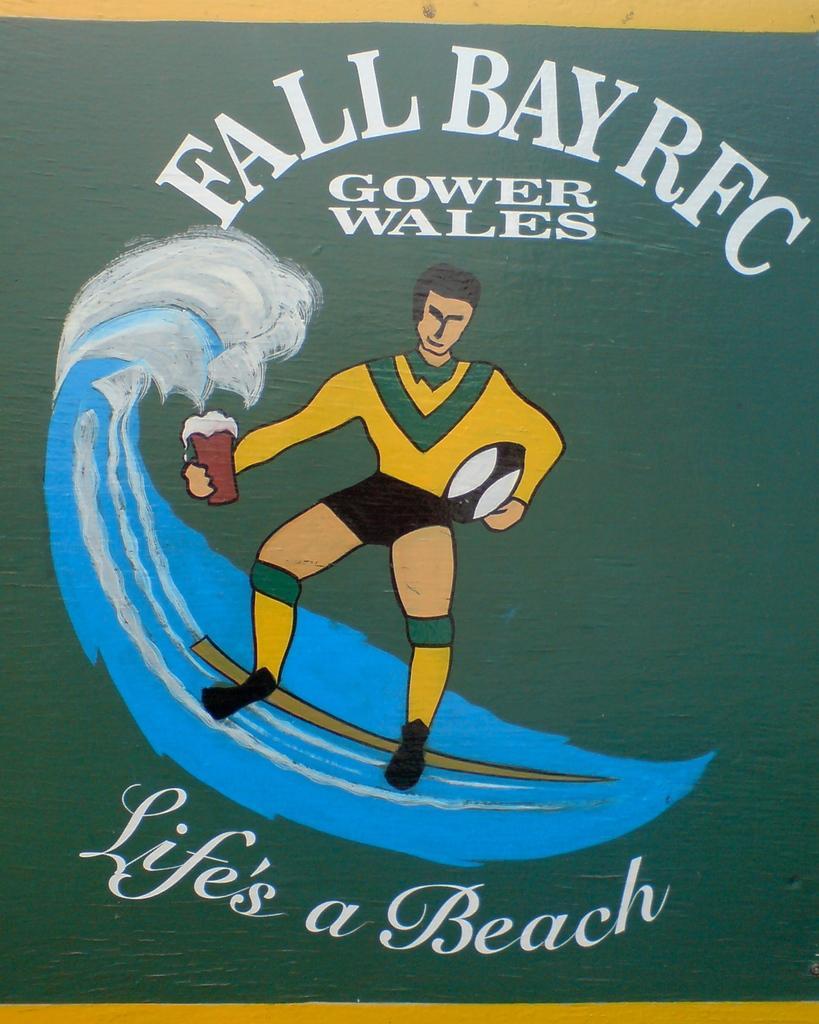In one or two sentences, can you explain what this image depicts? This is a poster and here we can see a person's image holding a cup and a ball and there is water and we can see some text written at the top and at the bottom. 